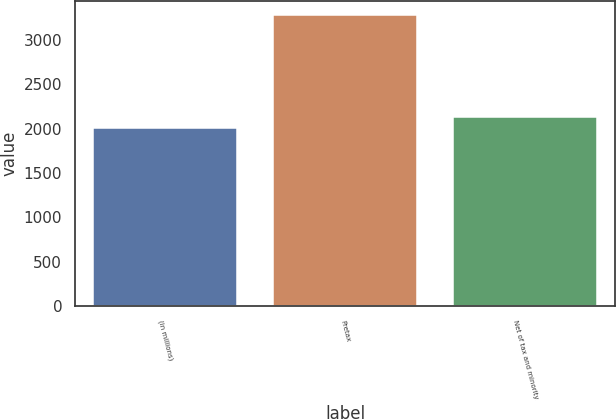Convert chart to OTSL. <chart><loc_0><loc_0><loc_500><loc_500><bar_chart><fcel>(in millions)<fcel>Pretax<fcel>Net of tax and minority<nl><fcel>2005<fcel>3280<fcel>2132.5<nl></chart> 